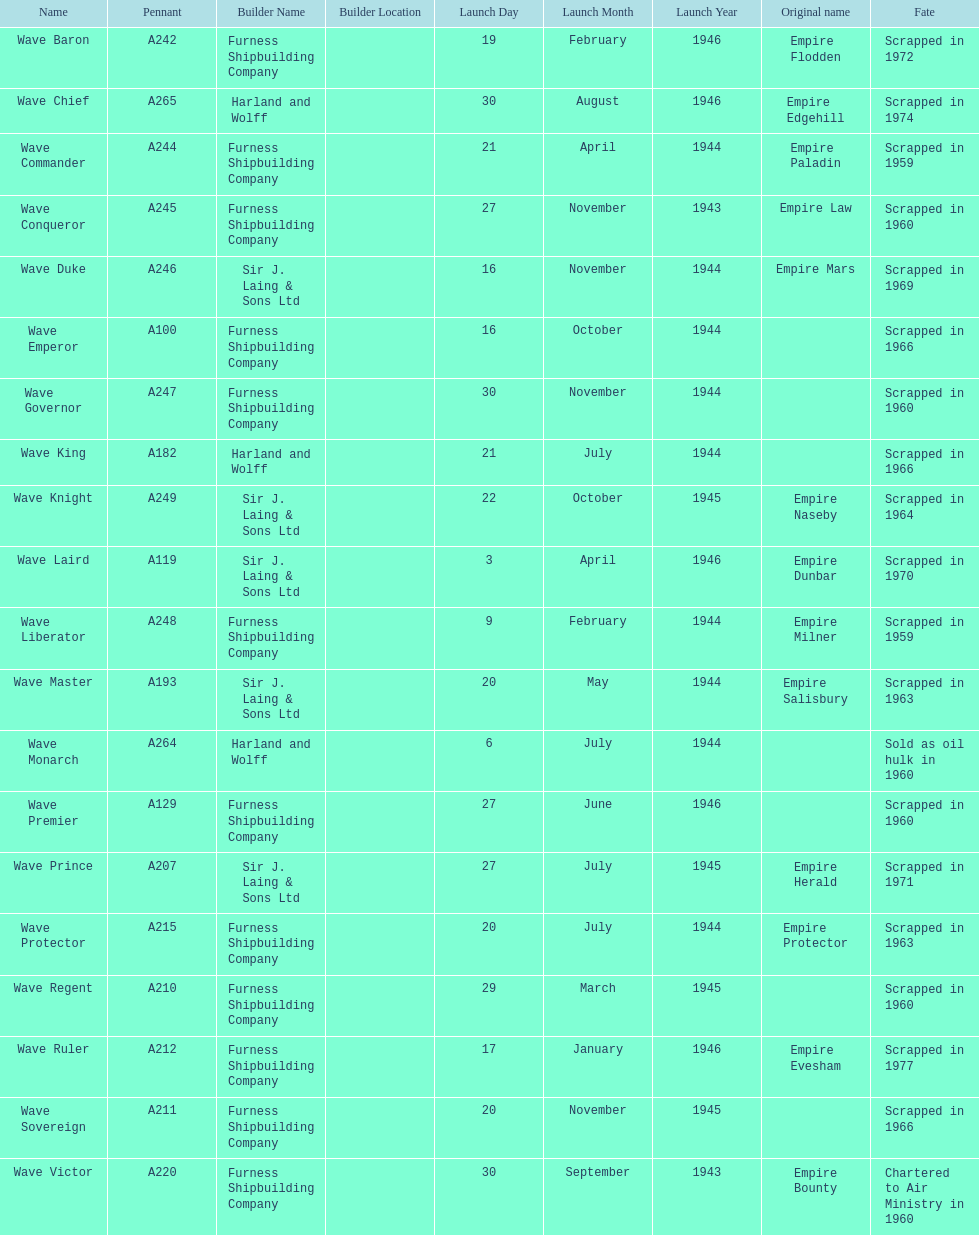What date was the first ship launched? 30 September 1943. 